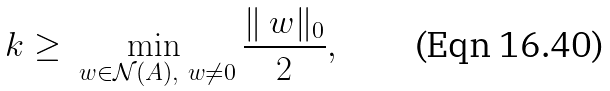<formula> <loc_0><loc_0><loc_500><loc_500>k \geq \min _ { \ w \in \mathcal { N } ( A ) , \ w \neq 0 } \frac { \| \ w \| _ { 0 } } { 2 } ,</formula> 